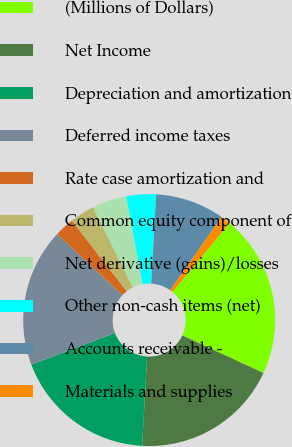<chart> <loc_0><loc_0><loc_500><loc_500><pie_chart><fcel>(Millions of Dollars)<fcel>Net Income<fcel>Depreciation and amortization<fcel>Deferred income taxes<fcel>Rate case amortization and<fcel>Common equity component of<fcel>Net derivative (gains)/losses<fcel>Other non-cash items (net)<fcel>Accounts receivable -<fcel>Materials and supplies<nl><fcel>20.88%<fcel>18.98%<fcel>18.35%<fcel>17.72%<fcel>2.53%<fcel>3.17%<fcel>4.43%<fcel>3.8%<fcel>8.86%<fcel>1.27%<nl></chart> 